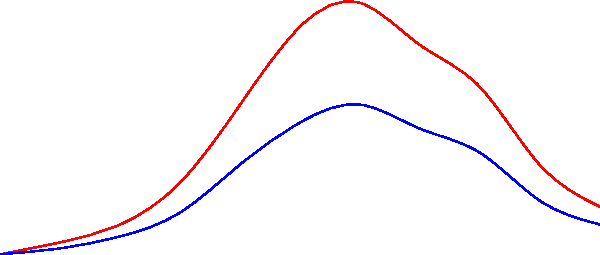Based on the seismic data shown in the graph, which represents P-waves and S-waves recorded during a seismic event, calculate the approximate depth of the earthquake focus. Assume the P-wave velocity is 6 km/s and the S-wave velocity is 3.5 km/s. To determine the depth of the earthquake focus, we'll follow these steps:

1. Identify the time difference between P-wave and S-wave arrivals:
   - The peak of the P-wave (red) occurs at 5 km on the x-axis
   - The peak of the S-wave (blue) also occurs at 5 km on the x-axis
   - This means the time difference (S-P interval) is 0 seconds

2. Calculate the distance to the epicenter:
   - When the S-P interval is 0, it indicates that the seismic station is directly above the focus

3. Use the P-wave arrival time to calculate the depth:
   - P-wave arrival time = 5 seconds (from the graph)
   - Distance = Velocity × Time
   - Depth = $6 \text{ km/s} \times 5 \text{ s} = 30 \text{ km}$

Therefore, the approximate depth of the earthquake focus is 30 km.
Answer: 30 km 